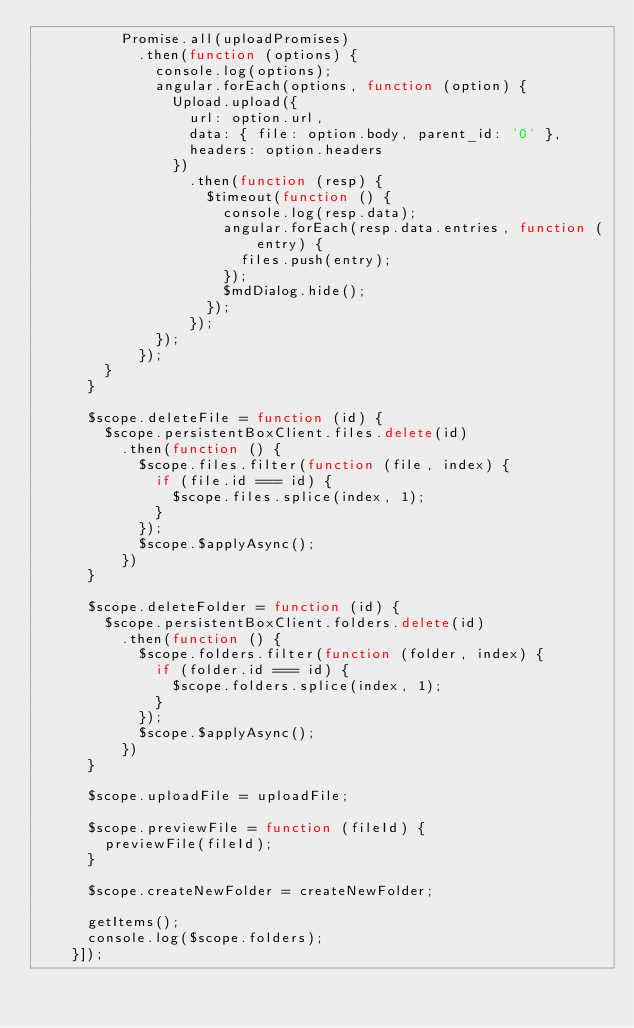Convert code to text. <code><loc_0><loc_0><loc_500><loc_500><_JavaScript_>          Promise.all(uploadPromises)
            .then(function (options) {
              console.log(options);
              angular.forEach(options, function (option) {
                Upload.upload({
                  url: option.url,
                  data: { file: option.body, parent_id: '0' },
                  headers: option.headers
                })
                  .then(function (resp) {
                    $timeout(function () {
                      console.log(resp.data);
                      angular.forEach(resp.data.entries, function (entry) {
                        files.push(entry);
                      });
                      $mdDialog.hide();
                    });
                  });
              });
            });
        }
      }

      $scope.deleteFile = function (id) {
        $scope.persistentBoxClient.files.delete(id)
          .then(function () {
            $scope.files.filter(function (file, index) {
              if (file.id === id) {
                $scope.files.splice(index, 1);
              }
            });
            $scope.$applyAsync();
          })
      }

      $scope.deleteFolder = function (id) {
        $scope.persistentBoxClient.folders.delete(id)
          .then(function () {
            $scope.folders.filter(function (folder, index) {
              if (folder.id === id) {
                $scope.folders.splice(index, 1);
              }
            });
            $scope.$applyAsync();
          })
      }

      $scope.uploadFile = uploadFile;

      $scope.previewFile = function (fileId) {
        previewFile(fileId);
      }

      $scope.createNewFolder = createNewFolder;

      getItems();
      console.log($scope.folders);
    }]);
</code> 